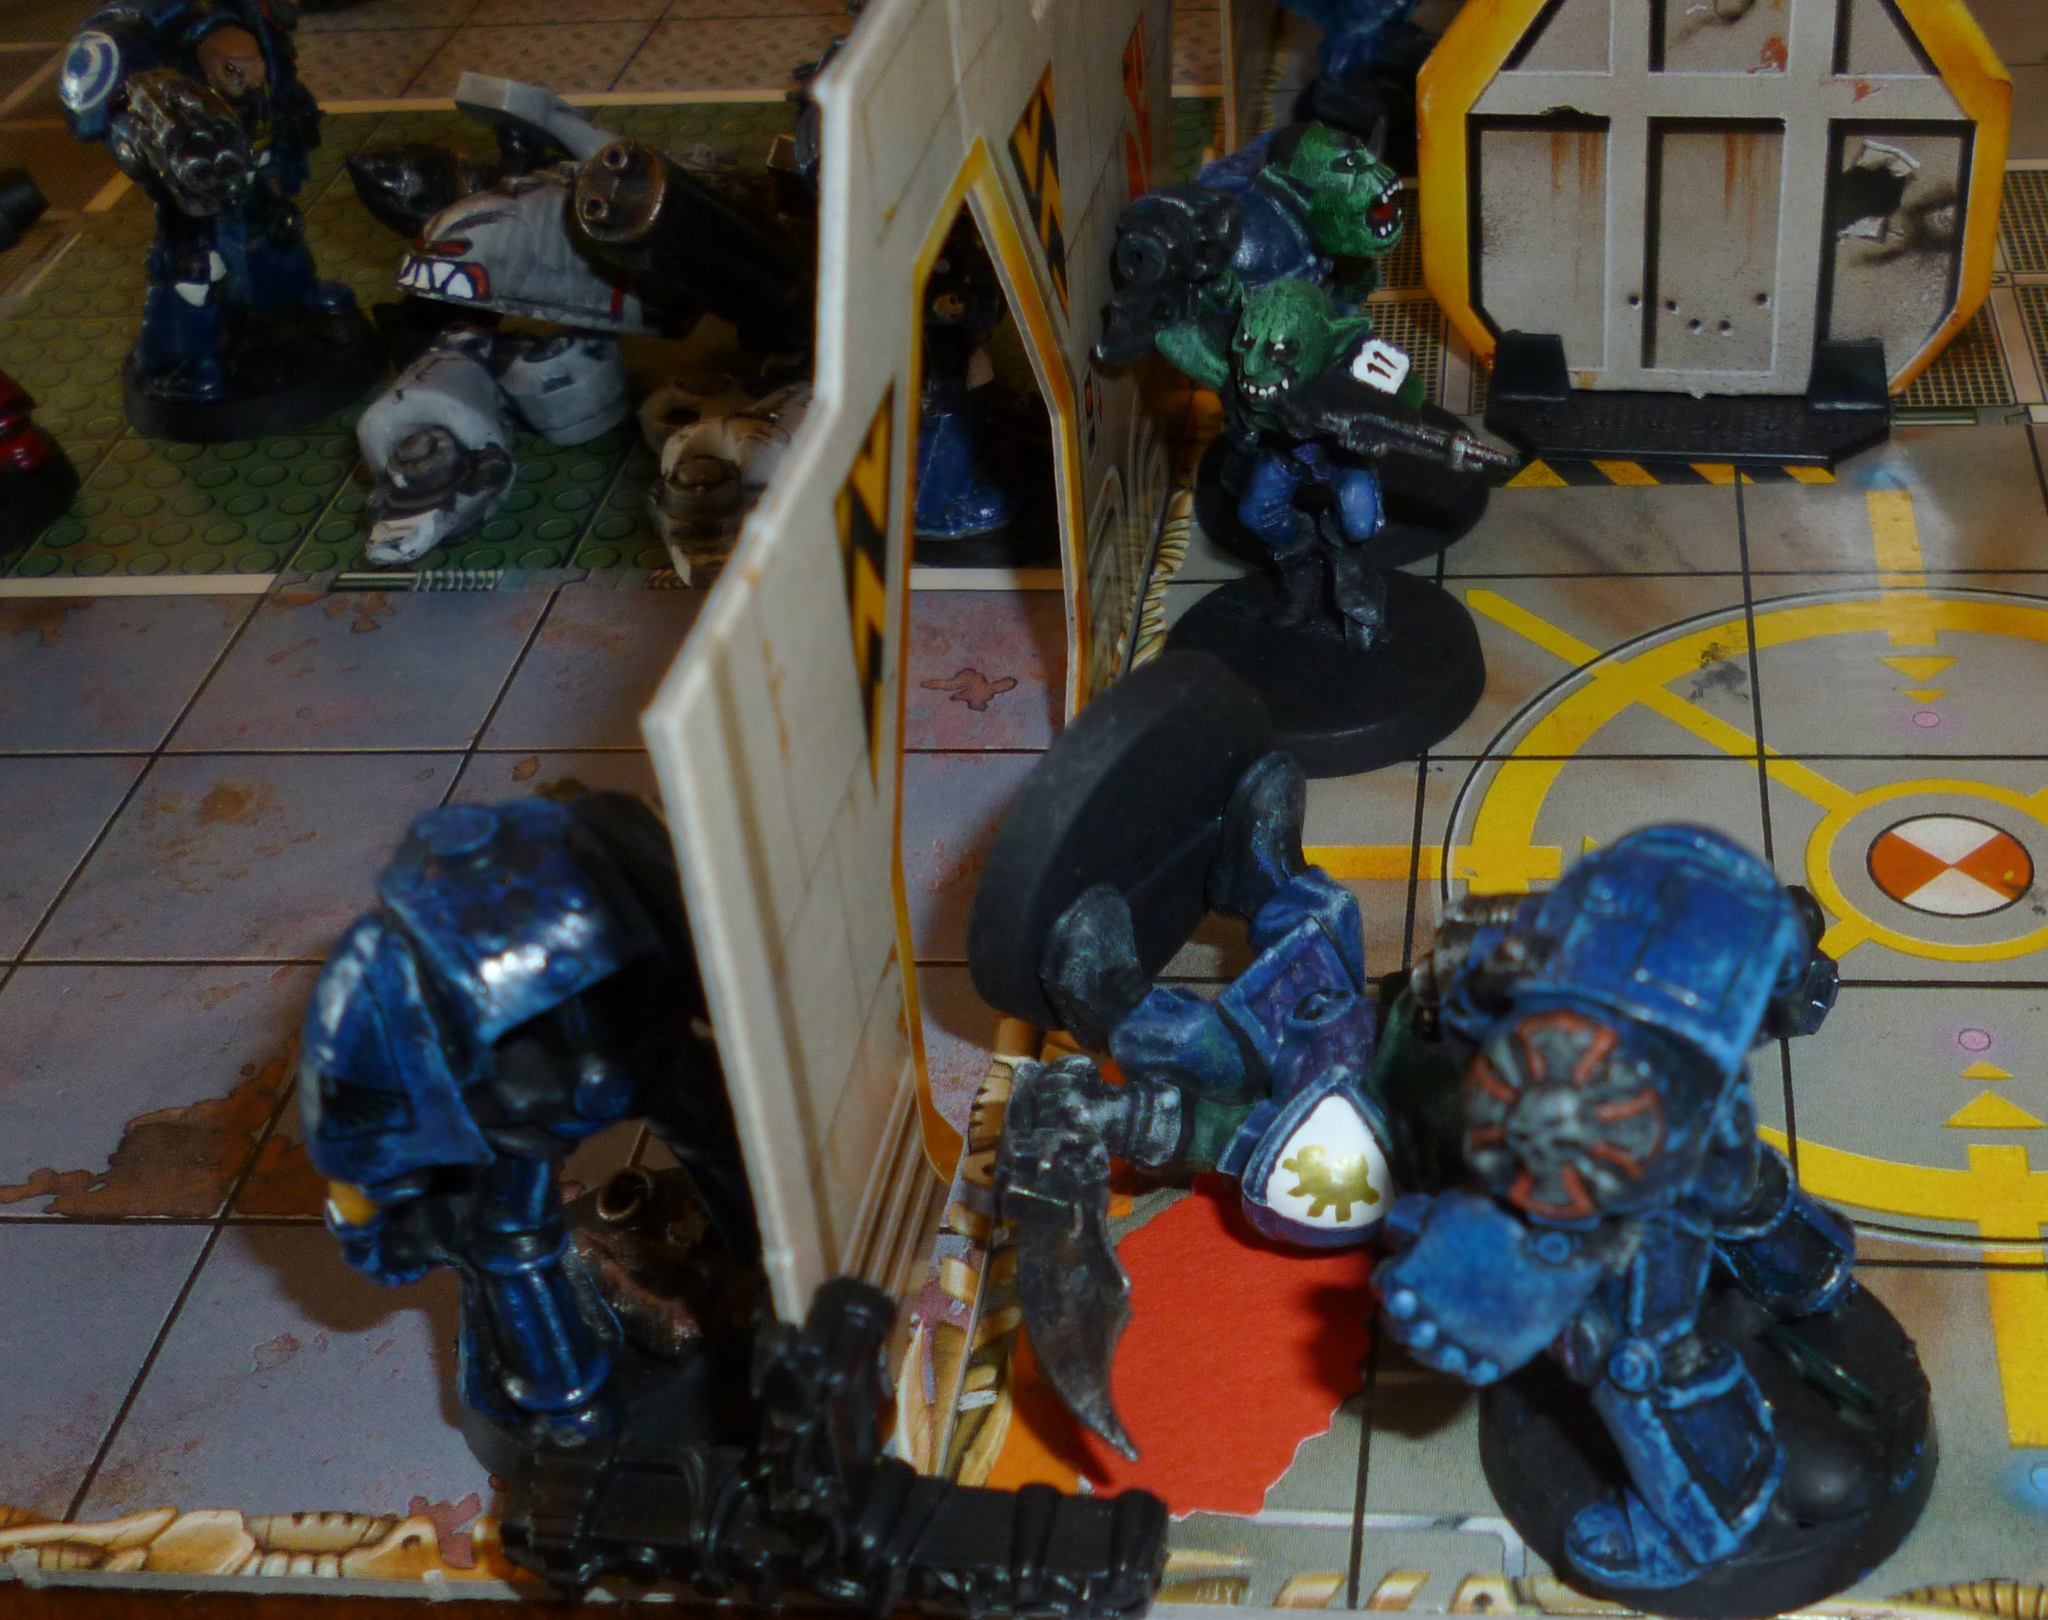Can you describe this image briefly? In the image there are many objects of different shapes, it seems like they are some toys. 